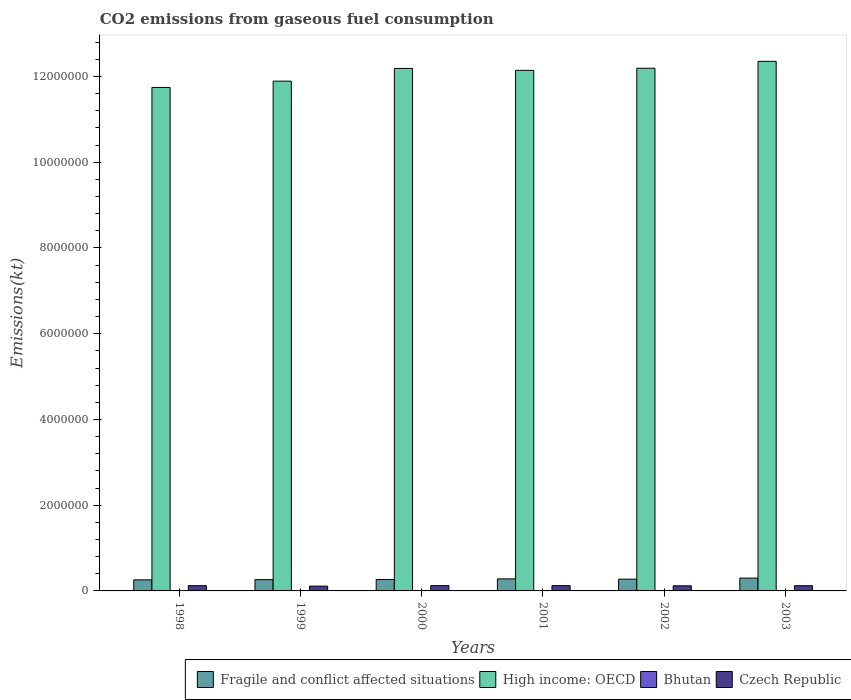How many different coloured bars are there?
Give a very brief answer. 4. How many groups of bars are there?
Offer a terse response. 6. Are the number of bars per tick equal to the number of legend labels?
Ensure brevity in your answer.  Yes. How many bars are there on the 1st tick from the left?
Ensure brevity in your answer.  4. What is the label of the 1st group of bars from the left?
Offer a very short reply. 1998. What is the amount of CO2 emitted in Fragile and conflict affected situations in 2000?
Your answer should be compact. 2.67e+05. Across all years, what is the maximum amount of CO2 emitted in Czech Republic?
Offer a very short reply. 1.24e+05. Across all years, what is the minimum amount of CO2 emitted in High income: OECD?
Provide a succinct answer. 1.17e+07. What is the total amount of CO2 emitted in Czech Republic in the graph?
Give a very brief answer. 7.23e+05. What is the difference between the amount of CO2 emitted in Czech Republic in 2002 and that in 2003?
Offer a very short reply. -2148.86. What is the difference between the amount of CO2 emitted in Czech Republic in 1998 and the amount of CO2 emitted in Bhutan in 1999?
Provide a short and direct response. 1.22e+05. What is the average amount of CO2 emitted in Bhutan per year?
Offer a very short reply. 392.37. In the year 2001, what is the difference between the amount of CO2 emitted in High income: OECD and amount of CO2 emitted in Fragile and conflict affected situations?
Provide a short and direct response. 1.19e+07. What is the ratio of the amount of CO2 emitted in Czech Republic in 2002 to that in 2003?
Your answer should be very brief. 0.98. Is the amount of CO2 emitted in Fragile and conflict affected situations in 1998 less than that in 2000?
Your answer should be very brief. Yes. Is the difference between the amount of CO2 emitted in High income: OECD in 1999 and 2001 greater than the difference between the amount of CO2 emitted in Fragile and conflict affected situations in 1999 and 2001?
Keep it short and to the point. No. What is the difference between the highest and the second highest amount of CO2 emitted in Bhutan?
Give a very brief answer. 18.34. What is the difference between the highest and the lowest amount of CO2 emitted in Fragile and conflict affected situations?
Keep it short and to the point. 4.06e+04. In how many years, is the amount of CO2 emitted in Czech Republic greater than the average amount of CO2 emitted in Czech Republic taken over all years?
Keep it short and to the point. 4. What does the 3rd bar from the left in 2002 represents?
Ensure brevity in your answer.  Bhutan. What does the 2nd bar from the right in 2002 represents?
Keep it short and to the point. Bhutan. Are all the bars in the graph horizontal?
Make the answer very short. No. How many years are there in the graph?
Ensure brevity in your answer.  6. Does the graph contain any zero values?
Ensure brevity in your answer.  No. Does the graph contain grids?
Offer a terse response. No. Where does the legend appear in the graph?
Provide a succinct answer. Bottom right. What is the title of the graph?
Offer a terse response. CO2 emissions from gaseous fuel consumption. What is the label or title of the Y-axis?
Keep it short and to the point. Emissions(kt). What is the Emissions(kt) in Fragile and conflict affected situations in 1998?
Your response must be concise. 2.58e+05. What is the Emissions(kt) in High income: OECD in 1998?
Offer a very short reply. 1.17e+07. What is the Emissions(kt) in Bhutan in 1998?
Give a very brief answer. 385.04. What is the Emissions(kt) in Czech Republic in 1998?
Make the answer very short. 1.22e+05. What is the Emissions(kt) of Fragile and conflict affected situations in 1999?
Offer a very short reply. 2.63e+05. What is the Emissions(kt) of High income: OECD in 1999?
Offer a terse response. 1.19e+07. What is the Emissions(kt) in Bhutan in 1999?
Keep it short and to the point. 385.04. What is the Emissions(kt) in Czech Republic in 1999?
Make the answer very short. 1.12e+05. What is the Emissions(kt) of Fragile and conflict affected situations in 2000?
Provide a short and direct response. 2.67e+05. What is the Emissions(kt) of High income: OECD in 2000?
Your answer should be very brief. 1.22e+07. What is the Emissions(kt) of Bhutan in 2000?
Your response must be concise. 399.7. What is the Emissions(kt) of Czech Republic in 2000?
Ensure brevity in your answer.  1.24e+05. What is the Emissions(kt) of Fragile and conflict affected situations in 2001?
Offer a terse response. 2.81e+05. What is the Emissions(kt) in High income: OECD in 2001?
Give a very brief answer. 1.21e+07. What is the Emissions(kt) in Bhutan in 2001?
Keep it short and to the point. 388.7. What is the Emissions(kt) of Czech Republic in 2001?
Provide a succinct answer. 1.24e+05. What is the Emissions(kt) in Fragile and conflict affected situations in 2002?
Ensure brevity in your answer.  2.74e+05. What is the Emissions(kt) in High income: OECD in 2002?
Ensure brevity in your answer.  1.22e+07. What is the Emissions(kt) of Bhutan in 2002?
Your answer should be very brief. 418.04. What is the Emissions(kt) in Czech Republic in 2002?
Ensure brevity in your answer.  1.20e+05. What is the Emissions(kt) in Fragile and conflict affected situations in 2003?
Ensure brevity in your answer.  2.99e+05. What is the Emissions(kt) of High income: OECD in 2003?
Provide a short and direct response. 1.24e+07. What is the Emissions(kt) in Bhutan in 2003?
Your response must be concise. 377.7. What is the Emissions(kt) in Czech Republic in 2003?
Provide a succinct answer. 1.22e+05. Across all years, what is the maximum Emissions(kt) in Fragile and conflict affected situations?
Offer a very short reply. 2.99e+05. Across all years, what is the maximum Emissions(kt) of High income: OECD?
Give a very brief answer. 1.24e+07. Across all years, what is the maximum Emissions(kt) in Bhutan?
Offer a very short reply. 418.04. Across all years, what is the maximum Emissions(kt) of Czech Republic?
Ensure brevity in your answer.  1.24e+05. Across all years, what is the minimum Emissions(kt) in Fragile and conflict affected situations?
Offer a very short reply. 2.58e+05. Across all years, what is the minimum Emissions(kt) in High income: OECD?
Your answer should be very brief. 1.17e+07. Across all years, what is the minimum Emissions(kt) in Bhutan?
Keep it short and to the point. 377.7. Across all years, what is the minimum Emissions(kt) of Czech Republic?
Keep it short and to the point. 1.12e+05. What is the total Emissions(kt) in Fragile and conflict affected situations in the graph?
Your answer should be very brief. 1.64e+06. What is the total Emissions(kt) of High income: OECD in the graph?
Provide a short and direct response. 7.25e+07. What is the total Emissions(kt) in Bhutan in the graph?
Provide a short and direct response. 2354.21. What is the total Emissions(kt) of Czech Republic in the graph?
Make the answer very short. 7.23e+05. What is the difference between the Emissions(kt) in Fragile and conflict affected situations in 1998 and that in 1999?
Offer a terse response. -5150.68. What is the difference between the Emissions(kt) of High income: OECD in 1998 and that in 1999?
Ensure brevity in your answer.  -1.47e+05. What is the difference between the Emissions(kt) of Czech Republic in 1998 and that in 1999?
Make the answer very short. 1.05e+04. What is the difference between the Emissions(kt) of Fragile and conflict affected situations in 1998 and that in 2000?
Provide a succinct answer. -9112.74. What is the difference between the Emissions(kt) of High income: OECD in 1998 and that in 2000?
Your answer should be very brief. -4.44e+05. What is the difference between the Emissions(kt) of Bhutan in 1998 and that in 2000?
Provide a short and direct response. -14.67. What is the difference between the Emissions(kt) in Czech Republic in 1998 and that in 2000?
Your response must be concise. -1213.78. What is the difference between the Emissions(kt) in Fragile and conflict affected situations in 1998 and that in 2001?
Provide a short and direct response. -2.26e+04. What is the difference between the Emissions(kt) in High income: OECD in 1998 and that in 2001?
Your answer should be very brief. -3.98e+05. What is the difference between the Emissions(kt) of Bhutan in 1998 and that in 2001?
Provide a short and direct response. -3.67. What is the difference between the Emissions(kt) in Czech Republic in 1998 and that in 2001?
Your answer should be compact. -1078.1. What is the difference between the Emissions(kt) in Fragile and conflict affected situations in 1998 and that in 2002?
Give a very brief answer. -1.61e+04. What is the difference between the Emissions(kt) in High income: OECD in 1998 and that in 2002?
Offer a very short reply. -4.48e+05. What is the difference between the Emissions(kt) in Bhutan in 1998 and that in 2002?
Ensure brevity in your answer.  -33. What is the difference between the Emissions(kt) in Czech Republic in 1998 and that in 2002?
Make the answer very short. 2918.93. What is the difference between the Emissions(kt) in Fragile and conflict affected situations in 1998 and that in 2003?
Keep it short and to the point. -4.06e+04. What is the difference between the Emissions(kt) of High income: OECD in 1998 and that in 2003?
Offer a very short reply. -6.08e+05. What is the difference between the Emissions(kt) in Bhutan in 1998 and that in 2003?
Offer a very short reply. 7.33. What is the difference between the Emissions(kt) in Czech Republic in 1998 and that in 2003?
Keep it short and to the point. 770.07. What is the difference between the Emissions(kt) in Fragile and conflict affected situations in 1999 and that in 2000?
Ensure brevity in your answer.  -3962.06. What is the difference between the Emissions(kt) of High income: OECD in 1999 and that in 2000?
Provide a short and direct response. -2.97e+05. What is the difference between the Emissions(kt) in Bhutan in 1999 and that in 2000?
Offer a terse response. -14.67. What is the difference between the Emissions(kt) of Czech Republic in 1999 and that in 2000?
Offer a terse response. -1.17e+04. What is the difference between the Emissions(kt) of Fragile and conflict affected situations in 1999 and that in 2001?
Ensure brevity in your answer.  -1.75e+04. What is the difference between the Emissions(kt) of High income: OECD in 1999 and that in 2001?
Offer a very short reply. -2.52e+05. What is the difference between the Emissions(kt) in Bhutan in 1999 and that in 2001?
Offer a terse response. -3.67. What is the difference between the Emissions(kt) of Czech Republic in 1999 and that in 2001?
Offer a very short reply. -1.16e+04. What is the difference between the Emissions(kt) of Fragile and conflict affected situations in 1999 and that in 2002?
Offer a terse response. -1.09e+04. What is the difference between the Emissions(kt) in High income: OECD in 1999 and that in 2002?
Your answer should be very brief. -3.01e+05. What is the difference between the Emissions(kt) of Bhutan in 1999 and that in 2002?
Provide a short and direct response. -33. What is the difference between the Emissions(kt) in Czech Republic in 1999 and that in 2002?
Keep it short and to the point. -7612.69. What is the difference between the Emissions(kt) in Fragile and conflict affected situations in 1999 and that in 2003?
Your response must be concise. -3.54e+04. What is the difference between the Emissions(kt) in High income: OECD in 1999 and that in 2003?
Offer a terse response. -4.62e+05. What is the difference between the Emissions(kt) of Bhutan in 1999 and that in 2003?
Your answer should be very brief. 7.33. What is the difference between the Emissions(kt) of Czech Republic in 1999 and that in 2003?
Your answer should be very brief. -9761.55. What is the difference between the Emissions(kt) of Fragile and conflict affected situations in 2000 and that in 2001?
Give a very brief answer. -1.35e+04. What is the difference between the Emissions(kt) of High income: OECD in 2000 and that in 2001?
Offer a very short reply. 4.55e+04. What is the difference between the Emissions(kt) of Bhutan in 2000 and that in 2001?
Provide a short and direct response. 11. What is the difference between the Emissions(kt) in Czech Republic in 2000 and that in 2001?
Ensure brevity in your answer.  135.68. What is the difference between the Emissions(kt) of Fragile and conflict affected situations in 2000 and that in 2002?
Ensure brevity in your answer.  -6938.62. What is the difference between the Emissions(kt) in High income: OECD in 2000 and that in 2002?
Offer a very short reply. -3920.02. What is the difference between the Emissions(kt) in Bhutan in 2000 and that in 2002?
Your response must be concise. -18.34. What is the difference between the Emissions(kt) of Czech Republic in 2000 and that in 2002?
Keep it short and to the point. 4132.71. What is the difference between the Emissions(kt) of Fragile and conflict affected situations in 2000 and that in 2003?
Ensure brevity in your answer.  -3.15e+04. What is the difference between the Emissions(kt) in High income: OECD in 2000 and that in 2003?
Keep it short and to the point. -1.65e+05. What is the difference between the Emissions(kt) of Bhutan in 2000 and that in 2003?
Your answer should be compact. 22. What is the difference between the Emissions(kt) of Czech Republic in 2000 and that in 2003?
Make the answer very short. 1983.85. What is the difference between the Emissions(kt) in Fragile and conflict affected situations in 2001 and that in 2002?
Your answer should be compact. 6591.69. What is the difference between the Emissions(kt) of High income: OECD in 2001 and that in 2002?
Your response must be concise. -4.94e+04. What is the difference between the Emissions(kt) in Bhutan in 2001 and that in 2002?
Make the answer very short. -29.34. What is the difference between the Emissions(kt) of Czech Republic in 2001 and that in 2002?
Your answer should be very brief. 3997.03. What is the difference between the Emissions(kt) in Fragile and conflict affected situations in 2001 and that in 2003?
Keep it short and to the point. -1.79e+04. What is the difference between the Emissions(kt) in High income: OECD in 2001 and that in 2003?
Provide a short and direct response. -2.10e+05. What is the difference between the Emissions(kt) of Bhutan in 2001 and that in 2003?
Offer a very short reply. 11. What is the difference between the Emissions(kt) in Czech Republic in 2001 and that in 2003?
Keep it short and to the point. 1848.17. What is the difference between the Emissions(kt) in Fragile and conflict affected situations in 2002 and that in 2003?
Provide a short and direct response. -2.45e+04. What is the difference between the Emissions(kt) of High income: OECD in 2002 and that in 2003?
Make the answer very short. -1.61e+05. What is the difference between the Emissions(kt) of Bhutan in 2002 and that in 2003?
Your response must be concise. 40.34. What is the difference between the Emissions(kt) in Czech Republic in 2002 and that in 2003?
Offer a very short reply. -2148.86. What is the difference between the Emissions(kt) in Fragile and conflict affected situations in 1998 and the Emissions(kt) in High income: OECD in 1999?
Keep it short and to the point. -1.16e+07. What is the difference between the Emissions(kt) of Fragile and conflict affected situations in 1998 and the Emissions(kt) of Bhutan in 1999?
Offer a very short reply. 2.58e+05. What is the difference between the Emissions(kt) of Fragile and conflict affected situations in 1998 and the Emissions(kt) of Czech Republic in 1999?
Keep it short and to the point. 1.46e+05. What is the difference between the Emissions(kt) of High income: OECD in 1998 and the Emissions(kt) of Bhutan in 1999?
Offer a very short reply. 1.17e+07. What is the difference between the Emissions(kt) in High income: OECD in 1998 and the Emissions(kt) in Czech Republic in 1999?
Give a very brief answer. 1.16e+07. What is the difference between the Emissions(kt) of Bhutan in 1998 and the Emissions(kt) of Czech Republic in 1999?
Offer a terse response. -1.12e+05. What is the difference between the Emissions(kt) of Fragile and conflict affected situations in 1998 and the Emissions(kt) of High income: OECD in 2000?
Offer a very short reply. -1.19e+07. What is the difference between the Emissions(kt) in Fragile and conflict affected situations in 1998 and the Emissions(kt) in Bhutan in 2000?
Give a very brief answer. 2.58e+05. What is the difference between the Emissions(kt) of Fragile and conflict affected situations in 1998 and the Emissions(kt) of Czech Republic in 2000?
Ensure brevity in your answer.  1.35e+05. What is the difference between the Emissions(kt) of High income: OECD in 1998 and the Emissions(kt) of Bhutan in 2000?
Provide a succinct answer. 1.17e+07. What is the difference between the Emissions(kt) of High income: OECD in 1998 and the Emissions(kt) of Czech Republic in 2000?
Your response must be concise. 1.16e+07. What is the difference between the Emissions(kt) in Bhutan in 1998 and the Emissions(kt) in Czech Republic in 2000?
Make the answer very short. -1.23e+05. What is the difference between the Emissions(kt) of Fragile and conflict affected situations in 1998 and the Emissions(kt) of High income: OECD in 2001?
Provide a succinct answer. -1.19e+07. What is the difference between the Emissions(kt) of Fragile and conflict affected situations in 1998 and the Emissions(kt) of Bhutan in 2001?
Ensure brevity in your answer.  2.58e+05. What is the difference between the Emissions(kt) in Fragile and conflict affected situations in 1998 and the Emissions(kt) in Czech Republic in 2001?
Offer a very short reply. 1.35e+05. What is the difference between the Emissions(kt) of High income: OECD in 1998 and the Emissions(kt) of Bhutan in 2001?
Keep it short and to the point. 1.17e+07. What is the difference between the Emissions(kt) in High income: OECD in 1998 and the Emissions(kt) in Czech Republic in 2001?
Offer a terse response. 1.16e+07. What is the difference between the Emissions(kt) in Bhutan in 1998 and the Emissions(kt) in Czech Republic in 2001?
Your answer should be compact. -1.23e+05. What is the difference between the Emissions(kt) in Fragile and conflict affected situations in 1998 and the Emissions(kt) in High income: OECD in 2002?
Offer a terse response. -1.19e+07. What is the difference between the Emissions(kt) in Fragile and conflict affected situations in 1998 and the Emissions(kt) in Bhutan in 2002?
Ensure brevity in your answer.  2.58e+05. What is the difference between the Emissions(kt) of Fragile and conflict affected situations in 1998 and the Emissions(kt) of Czech Republic in 2002?
Ensure brevity in your answer.  1.39e+05. What is the difference between the Emissions(kt) of High income: OECD in 1998 and the Emissions(kt) of Bhutan in 2002?
Keep it short and to the point. 1.17e+07. What is the difference between the Emissions(kt) in High income: OECD in 1998 and the Emissions(kt) in Czech Republic in 2002?
Make the answer very short. 1.16e+07. What is the difference between the Emissions(kt) in Bhutan in 1998 and the Emissions(kt) in Czech Republic in 2002?
Offer a terse response. -1.19e+05. What is the difference between the Emissions(kt) of Fragile and conflict affected situations in 1998 and the Emissions(kt) of High income: OECD in 2003?
Your answer should be very brief. -1.21e+07. What is the difference between the Emissions(kt) of Fragile and conflict affected situations in 1998 and the Emissions(kt) of Bhutan in 2003?
Your response must be concise. 2.58e+05. What is the difference between the Emissions(kt) in Fragile and conflict affected situations in 1998 and the Emissions(kt) in Czech Republic in 2003?
Ensure brevity in your answer.  1.37e+05. What is the difference between the Emissions(kt) of High income: OECD in 1998 and the Emissions(kt) of Bhutan in 2003?
Give a very brief answer. 1.17e+07. What is the difference between the Emissions(kt) in High income: OECD in 1998 and the Emissions(kt) in Czech Republic in 2003?
Provide a short and direct response. 1.16e+07. What is the difference between the Emissions(kt) of Bhutan in 1998 and the Emissions(kt) of Czech Republic in 2003?
Make the answer very short. -1.21e+05. What is the difference between the Emissions(kt) in Fragile and conflict affected situations in 1999 and the Emissions(kt) in High income: OECD in 2000?
Make the answer very short. -1.19e+07. What is the difference between the Emissions(kt) of Fragile and conflict affected situations in 1999 and the Emissions(kt) of Bhutan in 2000?
Give a very brief answer. 2.63e+05. What is the difference between the Emissions(kt) of Fragile and conflict affected situations in 1999 and the Emissions(kt) of Czech Republic in 2000?
Provide a short and direct response. 1.40e+05. What is the difference between the Emissions(kt) of High income: OECD in 1999 and the Emissions(kt) of Bhutan in 2000?
Give a very brief answer. 1.19e+07. What is the difference between the Emissions(kt) of High income: OECD in 1999 and the Emissions(kt) of Czech Republic in 2000?
Keep it short and to the point. 1.18e+07. What is the difference between the Emissions(kt) in Bhutan in 1999 and the Emissions(kt) in Czech Republic in 2000?
Give a very brief answer. -1.23e+05. What is the difference between the Emissions(kt) of Fragile and conflict affected situations in 1999 and the Emissions(kt) of High income: OECD in 2001?
Provide a short and direct response. -1.19e+07. What is the difference between the Emissions(kt) in Fragile and conflict affected situations in 1999 and the Emissions(kt) in Bhutan in 2001?
Offer a very short reply. 2.63e+05. What is the difference between the Emissions(kt) in Fragile and conflict affected situations in 1999 and the Emissions(kt) in Czech Republic in 2001?
Your answer should be compact. 1.40e+05. What is the difference between the Emissions(kt) in High income: OECD in 1999 and the Emissions(kt) in Bhutan in 2001?
Offer a very short reply. 1.19e+07. What is the difference between the Emissions(kt) in High income: OECD in 1999 and the Emissions(kt) in Czech Republic in 2001?
Your answer should be compact. 1.18e+07. What is the difference between the Emissions(kt) of Bhutan in 1999 and the Emissions(kt) of Czech Republic in 2001?
Make the answer very short. -1.23e+05. What is the difference between the Emissions(kt) of Fragile and conflict affected situations in 1999 and the Emissions(kt) of High income: OECD in 2002?
Offer a very short reply. -1.19e+07. What is the difference between the Emissions(kt) in Fragile and conflict affected situations in 1999 and the Emissions(kt) in Bhutan in 2002?
Provide a short and direct response. 2.63e+05. What is the difference between the Emissions(kt) of Fragile and conflict affected situations in 1999 and the Emissions(kt) of Czech Republic in 2002?
Provide a succinct answer. 1.44e+05. What is the difference between the Emissions(kt) of High income: OECD in 1999 and the Emissions(kt) of Bhutan in 2002?
Provide a succinct answer. 1.19e+07. What is the difference between the Emissions(kt) in High income: OECD in 1999 and the Emissions(kt) in Czech Republic in 2002?
Ensure brevity in your answer.  1.18e+07. What is the difference between the Emissions(kt) of Bhutan in 1999 and the Emissions(kt) of Czech Republic in 2002?
Provide a succinct answer. -1.19e+05. What is the difference between the Emissions(kt) of Fragile and conflict affected situations in 1999 and the Emissions(kt) of High income: OECD in 2003?
Give a very brief answer. -1.21e+07. What is the difference between the Emissions(kt) in Fragile and conflict affected situations in 1999 and the Emissions(kt) in Bhutan in 2003?
Offer a terse response. 2.63e+05. What is the difference between the Emissions(kt) of Fragile and conflict affected situations in 1999 and the Emissions(kt) of Czech Republic in 2003?
Your answer should be compact. 1.42e+05. What is the difference between the Emissions(kt) of High income: OECD in 1999 and the Emissions(kt) of Bhutan in 2003?
Your response must be concise. 1.19e+07. What is the difference between the Emissions(kt) of High income: OECD in 1999 and the Emissions(kt) of Czech Republic in 2003?
Your response must be concise. 1.18e+07. What is the difference between the Emissions(kt) in Bhutan in 1999 and the Emissions(kt) in Czech Republic in 2003?
Give a very brief answer. -1.21e+05. What is the difference between the Emissions(kt) in Fragile and conflict affected situations in 2000 and the Emissions(kt) in High income: OECD in 2001?
Your answer should be compact. -1.19e+07. What is the difference between the Emissions(kt) of Fragile and conflict affected situations in 2000 and the Emissions(kt) of Bhutan in 2001?
Ensure brevity in your answer.  2.67e+05. What is the difference between the Emissions(kt) in Fragile and conflict affected situations in 2000 and the Emissions(kt) in Czech Republic in 2001?
Ensure brevity in your answer.  1.44e+05. What is the difference between the Emissions(kt) in High income: OECD in 2000 and the Emissions(kt) in Bhutan in 2001?
Ensure brevity in your answer.  1.22e+07. What is the difference between the Emissions(kt) in High income: OECD in 2000 and the Emissions(kt) in Czech Republic in 2001?
Your response must be concise. 1.21e+07. What is the difference between the Emissions(kt) in Bhutan in 2000 and the Emissions(kt) in Czech Republic in 2001?
Offer a terse response. -1.23e+05. What is the difference between the Emissions(kt) of Fragile and conflict affected situations in 2000 and the Emissions(kt) of High income: OECD in 2002?
Provide a succinct answer. -1.19e+07. What is the difference between the Emissions(kt) in Fragile and conflict affected situations in 2000 and the Emissions(kt) in Bhutan in 2002?
Offer a very short reply. 2.67e+05. What is the difference between the Emissions(kt) in Fragile and conflict affected situations in 2000 and the Emissions(kt) in Czech Republic in 2002?
Provide a short and direct response. 1.48e+05. What is the difference between the Emissions(kt) in High income: OECD in 2000 and the Emissions(kt) in Bhutan in 2002?
Provide a succinct answer. 1.22e+07. What is the difference between the Emissions(kt) of High income: OECD in 2000 and the Emissions(kt) of Czech Republic in 2002?
Offer a terse response. 1.21e+07. What is the difference between the Emissions(kt) in Bhutan in 2000 and the Emissions(kt) in Czech Republic in 2002?
Provide a succinct answer. -1.19e+05. What is the difference between the Emissions(kt) of Fragile and conflict affected situations in 2000 and the Emissions(kt) of High income: OECD in 2003?
Offer a terse response. -1.21e+07. What is the difference between the Emissions(kt) of Fragile and conflict affected situations in 2000 and the Emissions(kt) of Bhutan in 2003?
Give a very brief answer. 2.67e+05. What is the difference between the Emissions(kt) of Fragile and conflict affected situations in 2000 and the Emissions(kt) of Czech Republic in 2003?
Offer a very short reply. 1.46e+05. What is the difference between the Emissions(kt) in High income: OECD in 2000 and the Emissions(kt) in Bhutan in 2003?
Give a very brief answer. 1.22e+07. What is the difference between the Emissions(kt) of High income: OECD in 2000 and the Emissions(kt) of Czech Republic in 2003?
Make the answer very short. 1.21e+07. What is the difference between the Emissions(kt) of Bhutan in 2000 and the Emissions(kt) of Czech Republic in 2003?
Your answer should be compact. -1.21e+05. What is the difference between the Emissions(kt) of Fragile and conflict affected situations in 2001 and the Emissions(kt) of High income: OECD in 2002?
Keep it short and to the point. -1.19e+07. What is the difference between the Emissions(kt) in Fragile and conflict affected situations in 2001 and the Emissions(kt) in Bhutan in 2002?
Keep it short and to the point. 2.81e+05. What is the difference between the Emissions(kt) in Fragile and conflict affected situations in 2001 and the Emissions(kt) in Czech Republic in 2002?
Make the answer very short. 1.61e+05. What is the difference between the Emissions(kt) of High income: OECD in 2001 and the Emissions(kt) of Bhutan in 2002?
Provide a succinct answer. 1.21e+07. What is the difference between the Emissions(kt) of High income: OECD in 2001 and the Emissions(kt) of Czech Republic in 2002?
Offer a very short reply. 1.20e+07. What is the difference between the Emissions(kt) of Bhutan in 2001 and the Emissions(kt) of Czech Republic in 2002?
Make the answer very short. -1.19e+05. What is the difference between the Emissions(kt) in Fragile and conflict affected situations in 2001 and the Emissions(kt) in High income: OECD in 2003?
Keep it short and to the point. -1.21e+07. What is the difference between the Emissions(kt) of Fragile and conflict affected situations in 2001 and the Emissions(kt) of Bhutan in 2003?
Your answer should be very brief. 2.81e+05. What is the difference between the Emissions(kt) of Fragile and conflict affected situations in 2001 and the Emissions(kt) of Czech Republic in 2003?
Provide a short and direct response. 1.59e+05. What is the difference between the Emissions(kt) of High income: OECD in 2001 and the Emissions(kt) of Bhutan in 2003?
Offer a terse response. 1.21e+07. What is the difference between the Emissions(kt) in High income: OECD in 2001 and the Emissions(kt) in Czech Republic in 2003?
Your answer should be very brief. 1.20e+07. What is the difference between the Emissions(kt) in Bhutan in 2001 and the Emissions(kt) in Czech Republic in 2003?
Offer a terse response. -1.21e+05. What is the difference between the Emissions(kt) in Fragile and conflict affected situations in 2002 and the Emissions(kt) in High income: OECD in 2003?
Offer a terse response. -1.21e+07. What is the difference between the Emissions(kt) in Fragile and conflict affected situations in 2002 and the Emissions(kt) in Bhutan in 2003?
Your answer should be compact. 2.74e+05. What is the difference between the Emissions(kt) in Fragile and conflict affected situations in 2002 and the Emissions(kt) in Czech Republic in 2003?
Give a very brief answer. 1.53e+05. What is the difference between the Emissions(kt) in High income: OECD in 2002 and the Emissions(kt) in Bhutan in 2003?
Provide a succinct answer. 1.22e+07. What is the difference between the Emissions(kt) in High income: OECD in 2002 and the Emissions(kt) in Czech Republic in 2003?
Make the answer very short. 1.21e+07. What is the difference between the Emissions(kt) in Bhutan in 2002 and the Emissions(kt) in Czech Republic in 2003?
Make the answer very short. -1.21e+05. What is the average Emissions(kt) of Fragile and conflict affected situations per year?
Make the answer very short. 2.74e+05. What is the average Emissions(kt) in High income: OECD per year?
Provide a short and direct response. 1.21e+07. What is the average Emissions(kt) in Bhutan per year?
Your answer should be compact. 392.37. What is the average Emissions(kt) in Czech Republic per year?
Give a very brief answer. 1.20e+05. In the year 1998, what is the difference between the Emissions(kt) in Fragile and conflict affected situations and Emissions(kt) in High income: OECD?
Keep it short and to the point. -1.15e+07. In the year 1998, what is the difference between the Emissions(kt) in Fragile and conflict affected situations and Emissions(kt) in Bhutan?
Keep it short and to the point. 2.58e+05. In the year 1998, what is the difference between the Emissions(kt) in Fragile and conflict affected situations and Emissions(kt) in Czech Republic?
Your answer should be compact. 1.36e+05. In the year 1998, what is the difference between the Emissions(kt) of High income: OECD and Emissions(kt) of Bhutan?
Ensure brevity in your answer.  1.17e+07. In the year 1998, what is the difference between the Emissions(kt) in High income: OECD and Emissions(kt) in Czech Republic?
Keep it short and to the point. 1.16e+07. In the year 1998, what is the difference between the Emissions(kt) of Bhutan and Emissions(kt) of Czech Republic?
Your answer should be compact. -1.22e+05. In the year 1999, what is the difference between the Emissions(kt) of Fragile and conflict affected situations and Emissions(kt) of High income: OECD?
Provide a short and direct response. -1.16e+07. In the year 1999, what is the difference between the Emissions(kt) of Fragile and conflict affected situations and Emissions(kt) of Bhutan?
Provide a succinct answer. 2.63e+05. In the year 1999, what is the difference between the Emissions(kt) of Fragile and conflict affected situations and Emissions(kt) of Czech Republic?
Your response must be concise. 1.52e+05. In the year 1999, what is the difference between the Emissions(kt) in High income: OECD and Emissions(kt) in Bhutan?
Give a very brief answer. 1.19e+07. In the year 1999, what is the difference between the Emissions(kt) in High income: OECD and Emissions(kt) in Czech Republic?
Provide a short and direct response. 1.18e+07. In the year 1999, what is the difference between the Emissions(kt) in Bhutan and Emissions(kt) in Czech Republic?
Your response must be concise. -1.12e+05. In the year 2000, what is the difference between the Emissions(kt) in Fragile and conflict affected situations and Emissions(kt) in High income: OECD?
Keep it short and to the point. -1.19e+07. In the year 2000, what is the difference between the Emissions(kt) of Fragile and conflict affected situations and Emissions(kt) of Bhutan?
Make the answer very short. 2.67e+05. In the year 2000, what is the difference between the Emissions(kt) in Fragile and conflict affected situations and Emissions(kt) in Czech Republic?
Make the answer very short. 1.44e+05. In the year 2000, what is the difference between the Emissions(kt) in High income: OECD and Emissions(kt) in Bhutan?
Your answer should be compact. 1.22e+07. In the year 2000, what is the difference between the Emissions(kt) in High income: OECD and Emissions(kt) in Czech Republic?
Your response must be concise. 1.21e+07. In the year 2000, what is the difference between the Emissions(kt) of Bhutan and Emissions(kt) of Czech Republic?
Your answer should be very brief. -1.23e+05. In the year 2001, what is the difference between the Emissions(kt) of Fragile and conflict affected situations and Emissions(kt) of High income: OECD?
Your answer should be compact. -1.19e+07. In the year 2001, what is the difference between the Emissions(kt) in Fragile and conflict affected situations and Emissions(kt) in Bhutan?
Offer a very short reply. 2.81e+05. In the year 2001, what is the difference between the Emissions(kt) of Fragile and conflict affected situations and Emissions(kt) of Czech Republic?
Offer a very short reply. 1.57e+05. In the year 2001, what is the difference between the Emissions(kt) in High income: OECD and Emissions(kt) in Bhutan?
Offer a very short reply. 1.21e+07. In the year 2001, what is the difference between the Emissions(kt) of High income: OECD and Emissions(kt) of Czech Republic?
Keep it short and to the point. 1.20e+07. In the year 2001, what is the difference between the Emissions(kt) in Bhutan and Emissions(kt) in Czech Republic?
Provide a succinct answer. -1.23e+05. In the year 2002, what is the difference between the Emissions(kt) in Fragile and conflict affected situations and Emissions(kt) in High income: OECD?
Provide a succinct answer. -1.19e+07. In the year 2002, what is the difference between the Emissions(kt) of Fragile and conflict affected situations and Emissions(kt) of Bhutan?
Give a very brief answer. 2.74e+05. In the year 2002, what is the difference between the Emissions(kt) of Fragile and conflict affected situations and Emissions(kt) of Czech Republic?
Give a very brief answer. 1.55e+05. In the year 2002, what is the difference between the Emissions(kt) of High income: OECD and Emissions(kt) of Bhutan?
Ensure brevity in your answer.  1.22e+07. In the year 2002, what is the difference between the Emissions(kt) of High income: OECD and Emissions(kt) of Czech Republic?
Ensure brevity in your answer.  1.21e+07. In the year 2002, what is the difference between the Emissions(kt) of Bhutan and Emissions(kt) of Czech Republic?
Make the answer very short. -1.19e+05. In the year 2003, what is the difference between the Emissions(kt) of Fragile and conflict affected situations and Emissions(kt) of High income: OECD?
Make the answer very short. -1.21e+07. In the year 2003, what is the difference between the Emissions(kt) in Fragile and conflict affected situations and Emissions(kt) in Bhutan?
Offer a terse response. 2.99e+05. In the year 2003, what is the difference between the Emissions(kt) in Fragile and conflict affected situations and Emissions(kt) in Czech Republic?
Give a very brief answer. 1.77e+05. In the year 2003, what is the difference between the Emissions(kt) in High income: OECD and Emissions(kt) in Bhutan?
Give a very brief answer. 1.24e+07. In the year 2003, what is the difference between the Emissions(kt) of High income: OECD and Emissions(kt) of Czech Republic?
Offer a terse response. 1.22e+07. In the year 2003, what is the difference between the Emissions(kt) in Bhutan and Emissions(kt) in Czech Republic?
Give a very brief answer. -1.21e+05. What is the ratio of the Emissions(kt) in Fragile and conflict affected situations in 1998 to that in 1999?
Your response must be concise. 0.98. What is the ratio of the Emissions(kt) of Czech Republic in 1998 to that in 1999?
Make the answer very short. 1.09. What is the ratio of the Emissions(kt) of Fragile and conflict affected situations in 1998 to that in 2000?
Make the answer very short. 0.97. What is the ratio of the Emissions(kt) in High income: OECD in 1998 to that in 2000?
Provide a short and direct response. 0.96. What is the ratio of the Emissions(kt) of Bhutan in 1998 to that in 2000?
Provide a succinct answer. 0.96. What is the ratio of the Emissions(kt) in Czech Republic in 1998 to that in 2000?
Make the answer very short. 0.99. What is the ratio of the Emissions(kt) of Fragile and conflict affected situations in 1998 to that in 2001?
Your answer should be compact. 0.92. What is the ratio of the Emissions(kt) of High income: OECD in 1998 to that in 2001?
Offer a terse response. 0.97. What is the ratio of the Emissions(kt) of Bhutan in 1998 to that in 2001?
Provide a short and direct response. 0.99. What is the ratio of the Emissions(kt) of Czech Republic in 1998 to that in 2001?
Provide a short and direct response. 0.99. What is the ratio of the Emissions(kt) in Fragile and conflict affected situations in 1998 to that in 2002?
Ensure brevity in your answer.  0.94. What is the ratio of the Emissions(kt) in High income: OECD in 1998 to that in 2002?
Offer a terse response. 0.96. What is the ratio of the Emissions(kt) in Bhutan in 1998 to that in 2002?
Make the answer very short. 0.92. What is the ratio of the Emissions(kt) of Czech Republic in 1998 to that in 2002?
Offer a terse response. 1.02. What is the ratio of the Emissions(kt) in Fragile and conflict affected situations in 1998 to that in 2003?
Your answer should be compact. 0.86. What is the ratio of the Emissions(kt) in High income: OECD in 1998 to that in 2003?
Keep it short and to the point. 0.95. What is the ratio of the Emissions(kt) of Bhutan in 1998 to that in 2003?
Provide a succinct answer. 1.02. What is the ratio of the Emissions(kt) in Czech Republic in 1998 to that in 2003?
Your answer should be compact. 1.01. What is the ratio of the Emissions(kt) in Fragile and conflict affected situations in 1999 to that in 2000?
Give a very brief answer. 0.99. What is the ratio of the Emissions(kt) of High income: OECD in 1999 to that in 2000?
Ensure brevity in your answer.  0.98. What is the ratio of the Emissions(kt) of Bhutan in 1999 to that in 2000?
Ensure brevity in your answer.  0.96. What is the ratio of the Emissions(kt) of Czech Republic in 1999 to that in 2000?
Offer a very short reply. 0.91. What is the ratio of the Emissions(kt) in Fragile and conflict affected situations in 1999 to that in 2001?
Your response must be concise. 0.94. What is the ratio of the Emissions(kt) of High income: OECD in 1999 to that in 2001?
Offer a terse response. 0.98. What is the ratio of the Emissions(kt) of Bhutan in 1999 to that in 2001?
Offer a very short reply. 0.99. What is the ratio of the Emissions(kt) of Czech Republic in 1999 to that in 2001?
Provide a short and direct response. 0.91. What is the ratio of the Emissions(kt) in Fragile and conflict affected situations in 1999 to that in 2002?
Keep it short and to the point. 0.96. What is the ratio of the Emissions(kt) in High income: OECD in 1999 to that in 2002?
Provide a succinct answer. 0.98. What is the ratio of the Emissions(kt) in Bhutan in 1999 to that in 2002?
Provide a short and direct response. 0.92. What is the ratio of the Emissions(kt) in Czech Republic in 1999 to that in 2002?
Keep it short and to the point. 0.94. What is the ratio of the Emissions(kt) of Fragile and conflict affected situations in 1999 to that in 2003?
Keep it short and to the point. 0.88. What is the ratio of the Emissions(kt) of High income: OECD in 1999 to that in 2003?
Make the answer very short. 0.96. What is the ratio of the Emissions(kt) in Bhutan in 1999 to that in 2003?
Keep it short and to the point. 1.02. What is the ratio of the Emissions(kt) in Czech Republic in 1999 to that in 2003?
Your answer should be very brief. 0.92. What is the ratio of the Emissions(kt) in Fragile and conflict affected situations in 2000 to that in 2001?
Offer a terse response. 0.95. What is the ratio of the Emissions(kt) of Bhutan in 2000 to that in 2001?
Provide a succinct answer. 1.03. What is the ratio of the Emissions(kt) in Fragile and conflict affected situations in 2000 to that in 2002?
Your answer should be very brief. 0.97. What is the ratio of the Emissions(kt) in High income: OECD in 2000 to that in 2002?
Make the answer very short. 1. What is the ratio of the Emissions(kt) in Bhutan in 2000 to that in 2002?
Your answer should be very brief. 0.96. What is the ratio of the Emissions(kt) of Czech Republic in 2000 to that in 2002?
Make the answer very short. 1.03. What is the ratio of the Emissions(kt) in Fragile and conflict affected situations in 2000 to that in 2003?
Your answer should be very brief. 0.89. What is the ratio of the Emissions(kt) of High income: OECD in 2000 to that in 2003?
Your answer should be very brief. 0.99. What is the ratio of the Emissions(kt) of Bhutan in 2000 to that in 2003?
Your response must be concise. 1.06. What is the ratio of the Emissions(kt) in Czech Republic in 2000 to that in 2003?
Your answer should be compact. 1.02. What is the ratio of the Emissions(kt) of Fragile and conflict affected situations in 2001 to that in 2002?
Keep it short and to the point. 1.02. What is the ratio of the Emissions(kt) of High income: OECD in 2001 to that in 2002?
Your answer should be compact. 1. What is the ratio of the Emissions(kt) of Bhutan in 2001 to that in 2002?
Make the answer very short. 0.93. What is the ratio of the Emissions(kt) in Czech Republic in 2001 to that in 2002?
Provide a succinct answer. 1.03. What is the ratio of the Emissions(kt) of High income: OECD in 2001 to that in 2003?
Make the answer very short. 0.98. What is the ratio of the Emissions(kt) of Bhutan in 2001 to that in 2003?
Your response must be concise. 1.03. What is the ratio of the Emissions(kt) of Czech Republic in 2001 to that in 2003?
Give a very brief answer. 1.02. What is the ratio of the Emissions(kt) of Fragile and conflict affected situations in 2002 to that in 2003?
Make the answer very short. 0.92. What is the ratio of the Emissions(kt) of High income: OECD in 2002 to that in 2003?
Your answer should be compact. 0.99. What is the ratio of the Emissions(kt) in Bhutan in 2002 to that in 2003?
Your answer should be compact. 1.11. What is the ratio of the Emissions(kt) in Czech Republic in 2002 to that in 2003?
Give a very brief answer. 0.98. What is the difference between the highest and the second highest Emissions(kt) of Fragile and conflict affected situations?
Offer a terse response. 1.79e+04. What is the difference between the highest and the second highest Emissions(kt) of High income: OECD?
Your response must be concise. 1.61e+05. What is the difference between the highest and the second highest Emissions(kt) of Bhutan?
Your answer should be very brief. 18.34. What is the difference between the highest and the second highest Emissions(kt) in Czech Republic?
Ensure brevity in your answer.  135.68. What is the difference between the highest and the lowest Emissions(kt) of Fragile and conflict affected situations?
Provide a short and direct response. 4.06e+04. What is the difference between the highest and the lowest Emissions(kt) of High income: OECD?
Make the answer very short. 6.08e+05. What is the difference between the highest and the lowest Emissions(kt) of Bhutan?
Your answer should be very brief. 40.34. What is the difference between the highest and the lowest Emissions(kt) in Czech Republic?
Ensure brevity in your answer.  1.17e+04. 